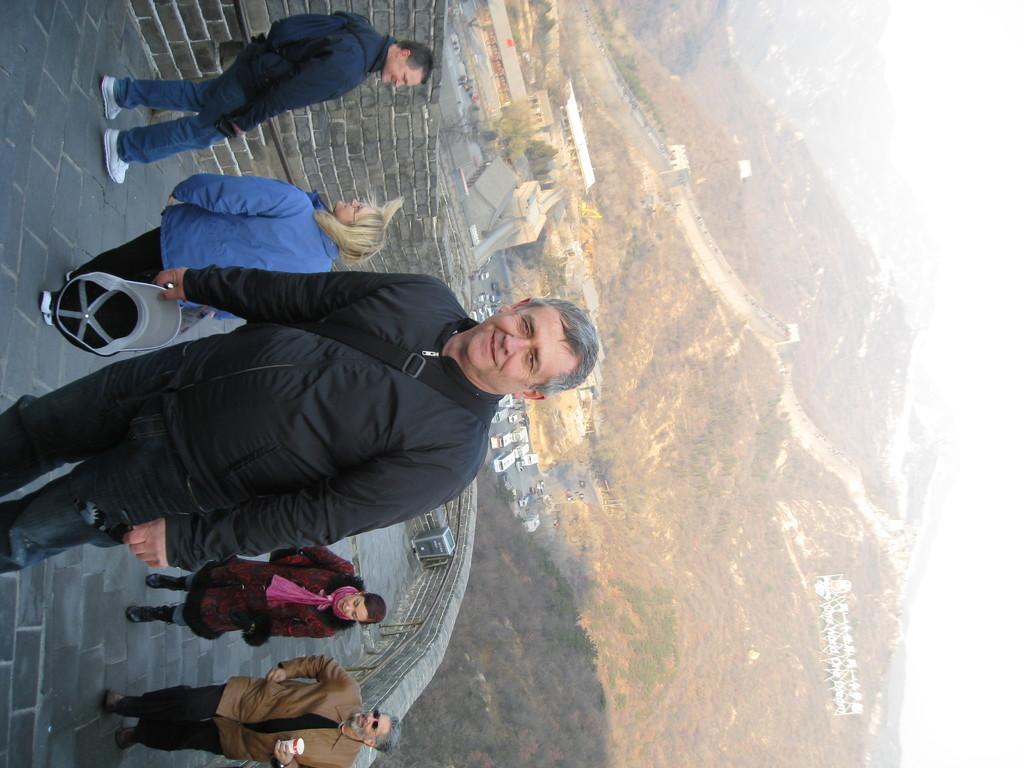How would you summarize this image in a sentence or two? In this image, we can see people wearing bags and coats and some are holding some objects. In the background, there are hills and we can see some sheds and some vehicles on the road. 